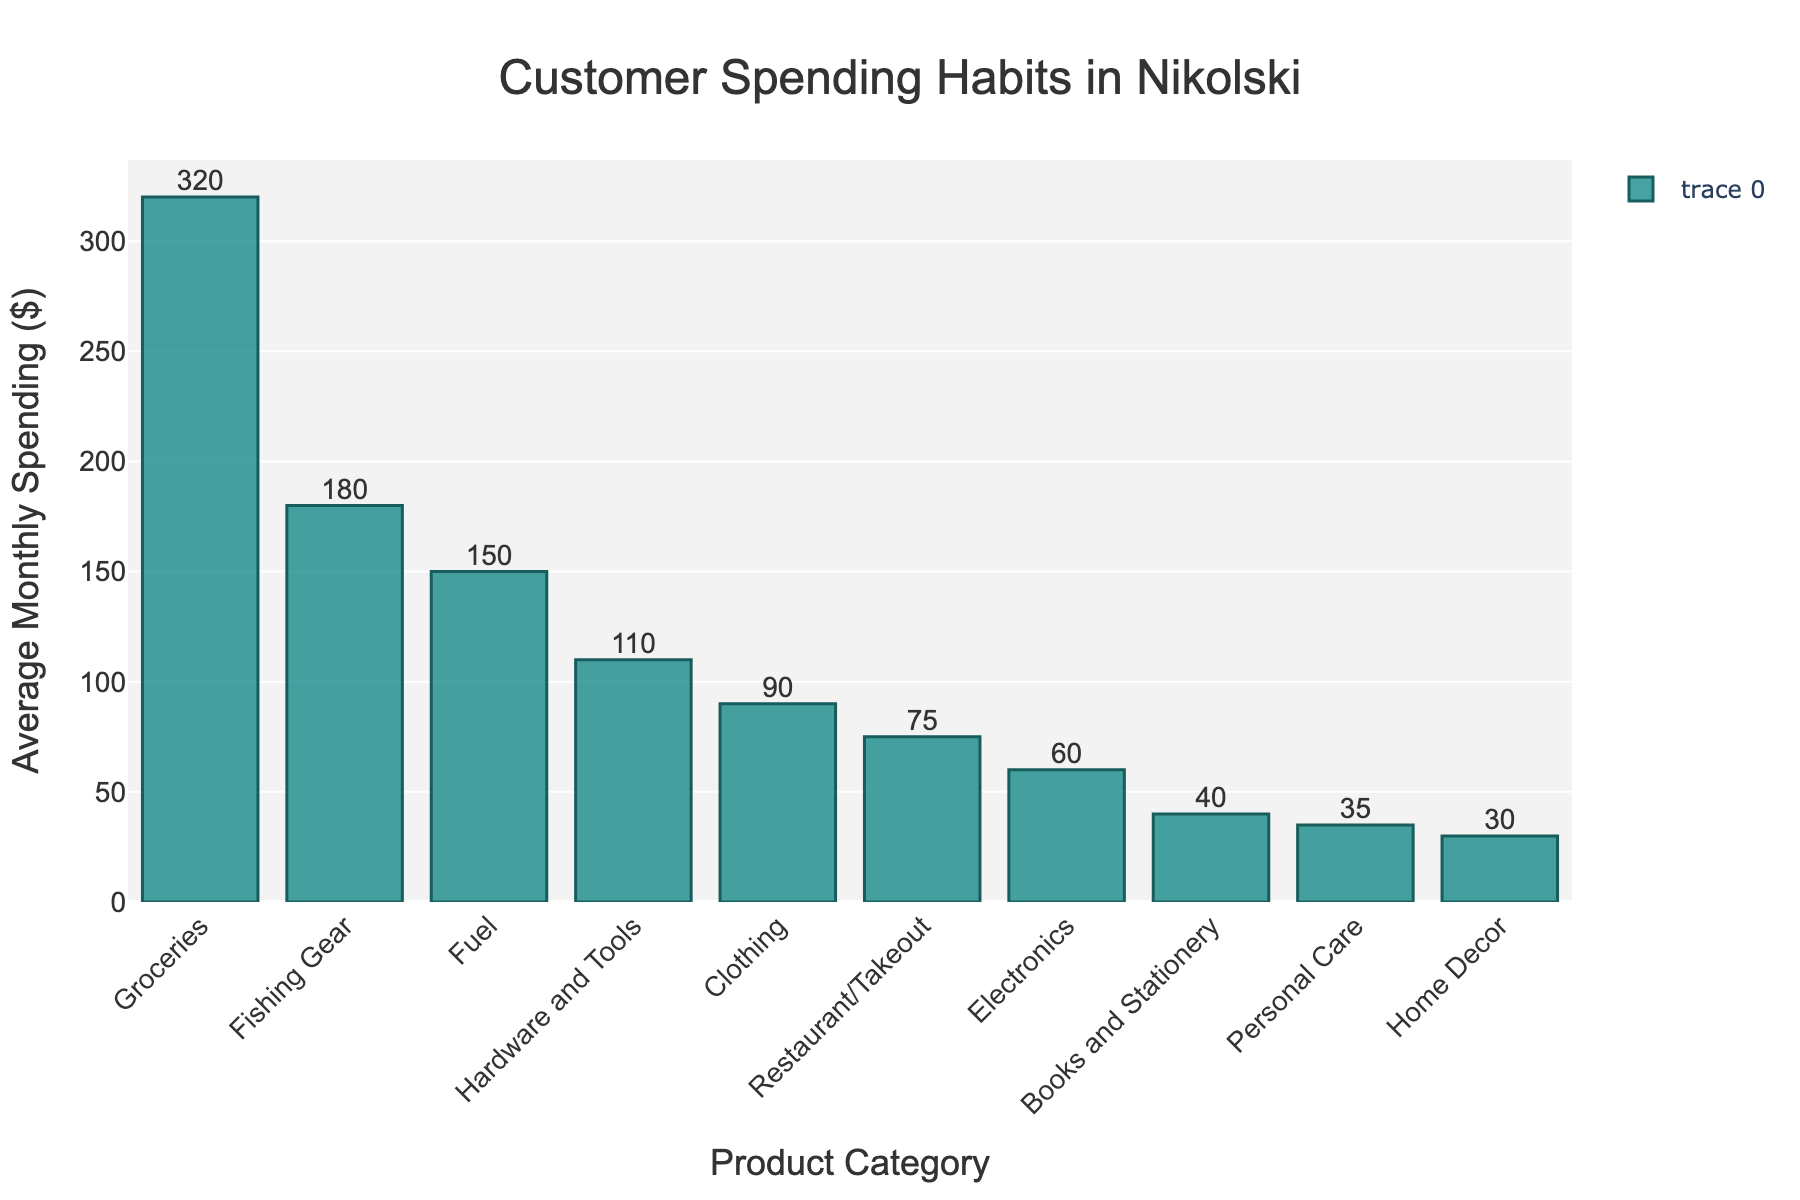what are the top three categories with the highest average monthly spending? The top three categories can be identified by looking at the tallest bars in the chart. The bars from tallest to shortest should be observed to determine the ranking.
Answer: Groceries, Fishing Gear, Fuel How much more do customers spend on groceries compared to clothing on average each month? To find the difference, subtract the average monthly spending on clothing from that of groceries. This is calculated as $320 (Groceries) - $90 (Clothing).
Answer: $230 Which category has the least average monthly spending? The least spending can be identified by looking for the shortest bar in the bar chart.
Answer: Home Decor What is the total average monthly spending across all categories? To find the total average monthly spending, sum the values of average monthly spending for all listed categories. The values are $320, $180, $150, $110, $90, $75, $60, $40, $35, and $30, which adds up to $1090.
Answer: $1090 Which categories have an average monthly spending of less than $50? To identify these categories, look for bars that are shorter and below the $50 mark on the y-axis.
Answer: Books and Stationery, Personal Care, Home Decor How many categories have an average monthly spending between $100 and $200? Count the number of bars that fall within the range of $100 to $200 on the y-axis.
Answer: 2 By how much does the average monthly spending on electronics differ from restaurant/takeout? Subtract the average monthly spending on electronics from that on restaurant/takeout. This is calculated as $75 (Restaurant/Takeout) - $60 (Electronics).
Answer: $15 What's the average monthly spending for categories related to home (Home Decor and Hardware and Tools)? Add the average monthly spending for Home Decor and Hardware and Tools, then find the average. This is calculated as ($110 + $30) / 2.
Answer: $70 Which categories have average monthly spending numbers that are multiples of $30? Look for bars representing categories whose values are exactly divisible by $30.
Answer: Groceries, Fuel, Books and Stationery, Home Decor Which category has a higher average monthly spending: Fishing Gear or Fuel? Compare the heights of the bars representing Fishing Gear and Fuel.
Answer: Fishing Gear 